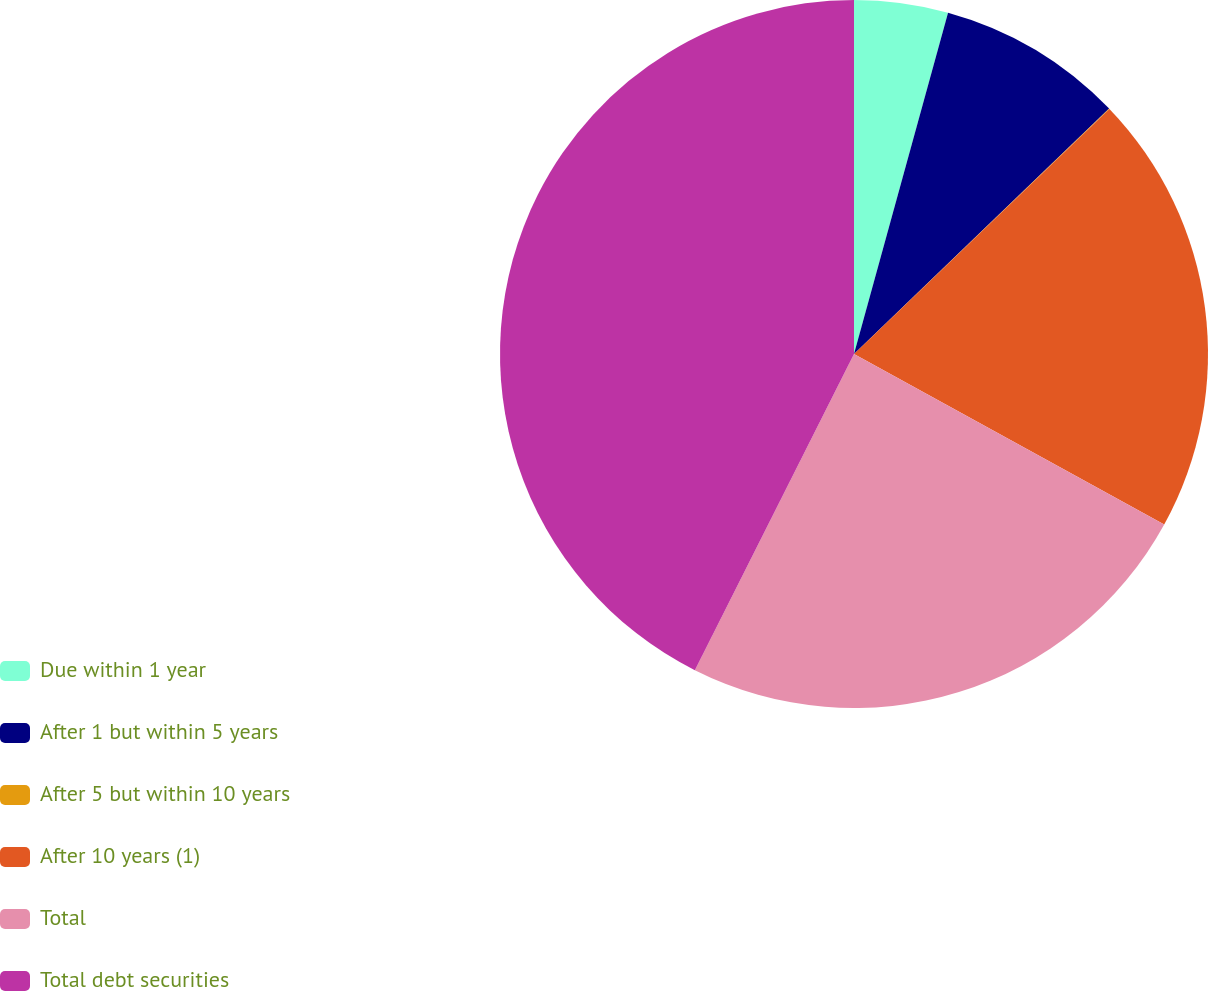Convert chart. <chart><loc_0><loc_0><loc_500><loc_500><pie_chart><fcel>Due within 1 year<fcel>After 1 but within 5 years<fcel>After 5 but within 10 years<fcel>After 10 years (1)<fcel>Total<fcel>Total debt securities<nl><fcel>4.28%<fcel>8.53%<fcel>0.02%<fcel>20.17%<fcel>24.42%<fcel>42.58%<nl></chart> 